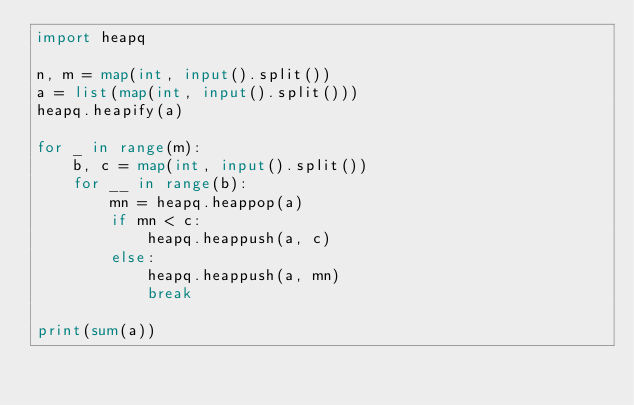<code> <loc_0><loc_0><loc_500><loc_500><_Python_>import heapq

n, m = map(int, input().split())
a = list(map(int, input().split()))
heapq.heapify(a)

for _ in range(m):
    b, c = map(int, input().split())
    for __ in range(b):
        mn = heapq.heappop(a)
        if mn < c:
            heapq.heappush(a, c)
        else:
            heapq.heappush(a, mn)
            break

print(sum(a))</code> 